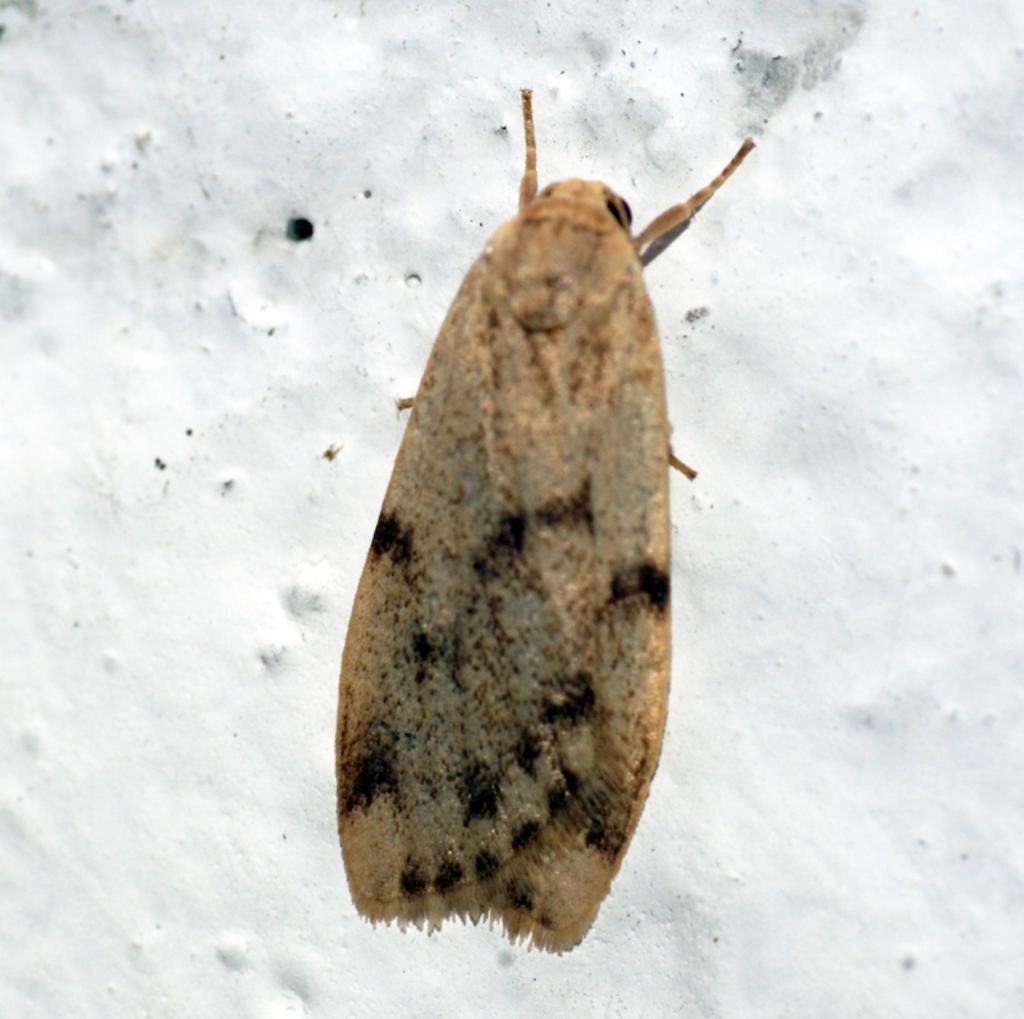What type of creature is present in the image? There is an insect in the image. Where is the insect located? The insect is on the wall. What idea does the ladybug have in the image? There is no ladybug present in the image, and therefore no idea can be attributed to it. 